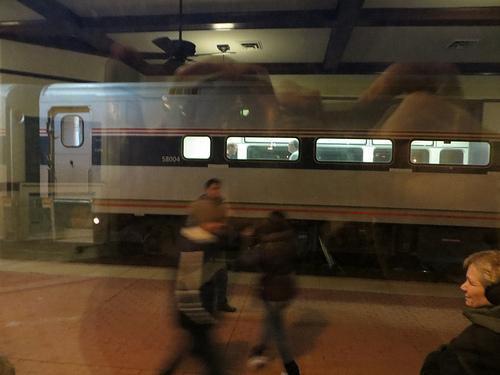How many windows are shown?
Give a very brief answer. 4. 